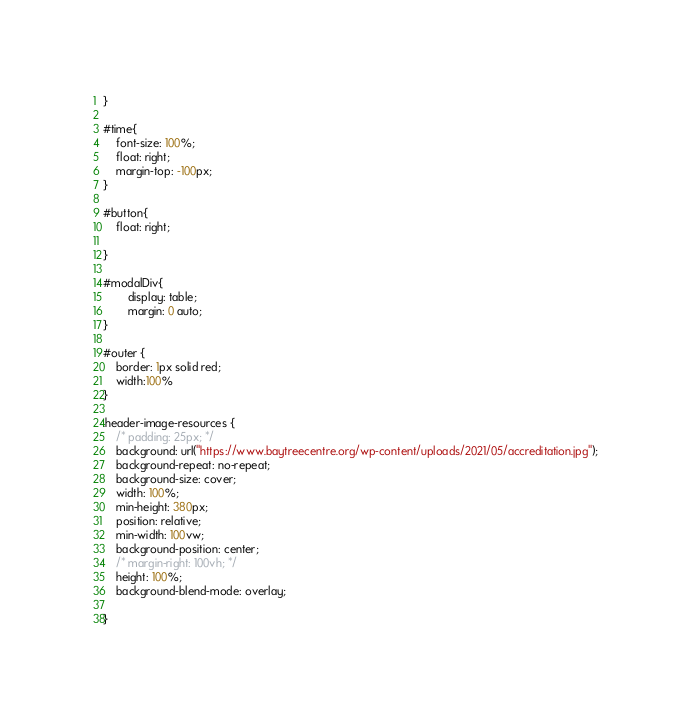Convert code to text. <code><loc_0><loc_0><loc_500><loc_500><_CSS_>}

#time{
    font-size: 100%;
    float: right;
    margin-top: -100px;
}

#button{
    float: right;
    
}

#modalDiv{
        display: table;
        margin: 0 auto;
}

#outer {
    border: 1px solid red;
    width:100%
}

.header-image-resources {
    /* padding: 25px; */
    background: url("https://www.baytreecentre.org/wp-content/uploads/2021/05/accreditation.jpg");
    background-repeat: no-repeat;
    background-size: cover;
    width: 100%;
    min-height: 380px;
    position: relative;
    min-width: 100vw;
    background-position: center;
    /* margin-right: 100vh; */
    height: 100%;
    background-blend-mode: overlay;

}

</code> 